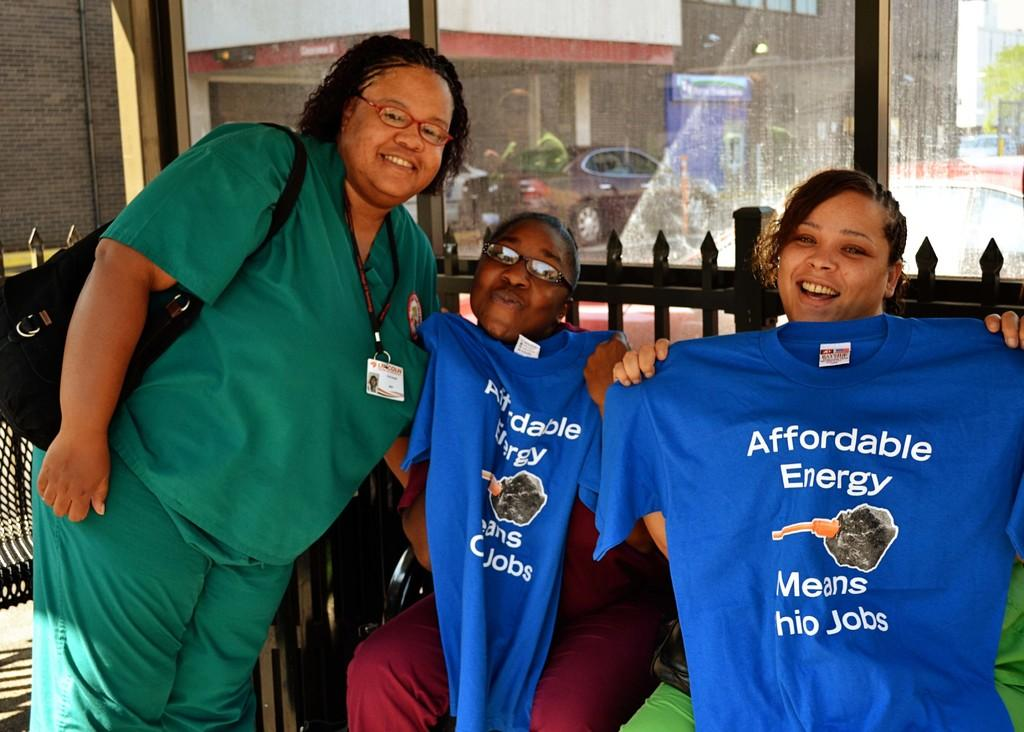<image>
Describe the image concisely. Three ladies, two of whom are holding up blue shirts that say Affordable Energy Means Ohio Jobs. 